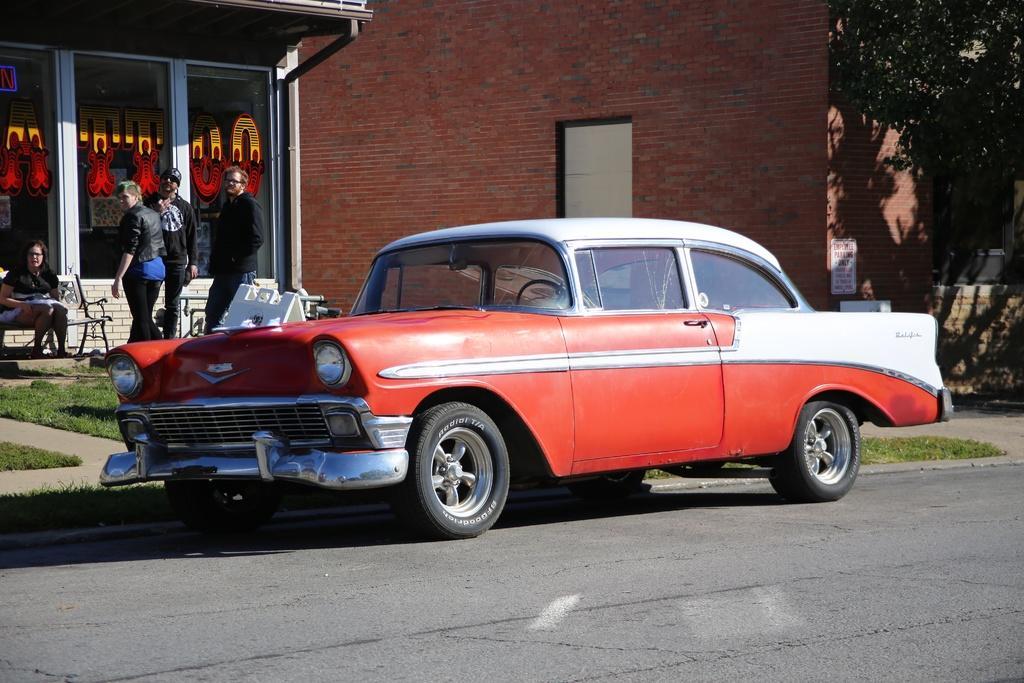In one or two sentences, can you explain what this image depicts? This image is clicked on the road. there is a car parked on the road. Behind the car there's grass on the ground. In the background there is a wall of a building. To the left there is text on the glass walls. There are people standing in front of the wall. There is a woman sitting on the bench. to the right there are leaves of a tree. 